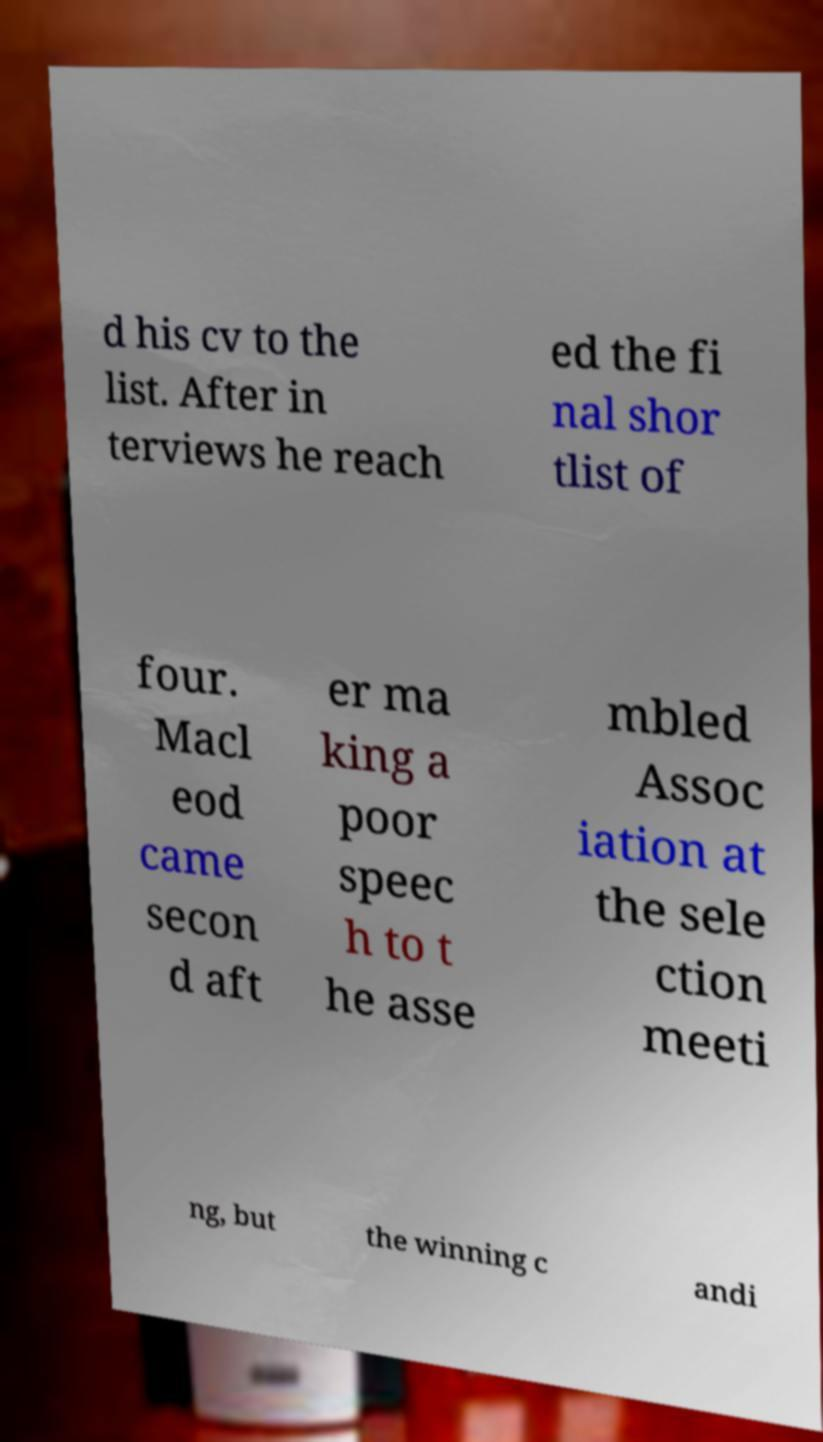For documentation purposes, I need the text within this image transcribed. Could you provide that? d his cv to the list. After in terviews he reach ed the fi nal shor tlist of four. Macl eod came secon d aft er ma king a poor speec h to t he asse mbled Assoc iation at the sele ction meeti ng, but the winning c andi 